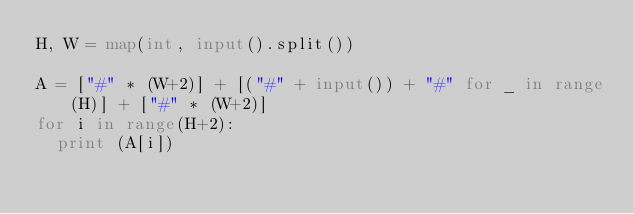Convert code to text. <code><loc_0><loc_0><loc_500><loc_500><_Python_>H, W = map(int, input().split())

A = ["#" * (W+2)] + [("#" + input()) + "#" for _ in range(H)] + ["#" * (W+2)]
for i in range(H+2):
  print (A[i])
</code> 